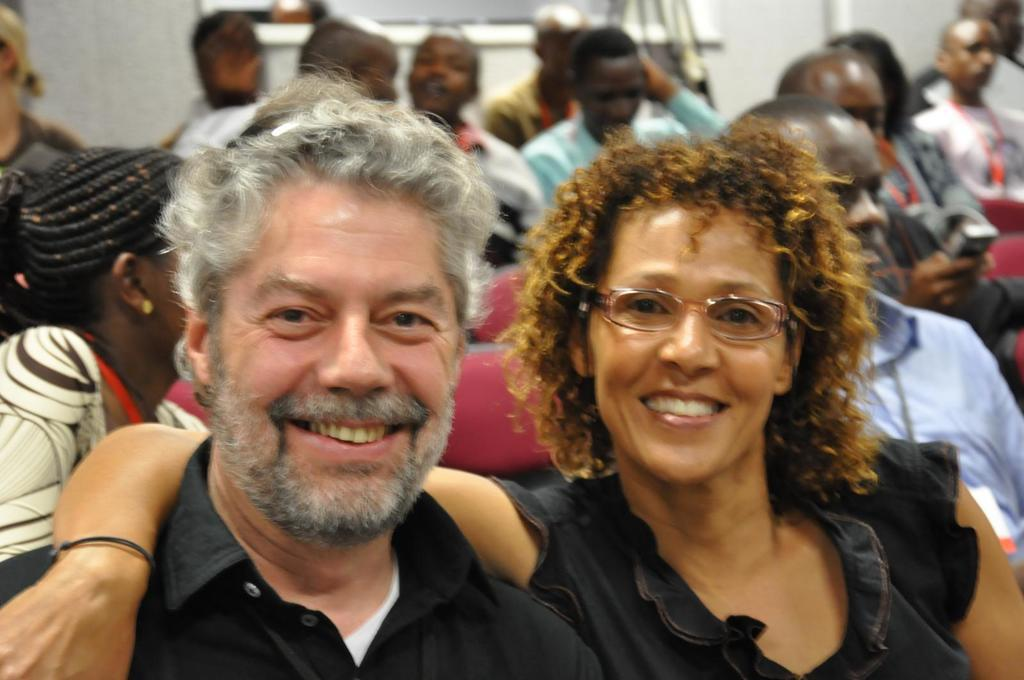Who is the main subject in the image? There is a woman in the image. What is the woman doing with her hand? The woman has her hand placed on a person beside her. Are there any other people in the image? Yes, there are other persons sitting behind the woman and the person beside her. What type of organization is the woman representing in the image? There is no indication in the image that the woman is representing any organization. 